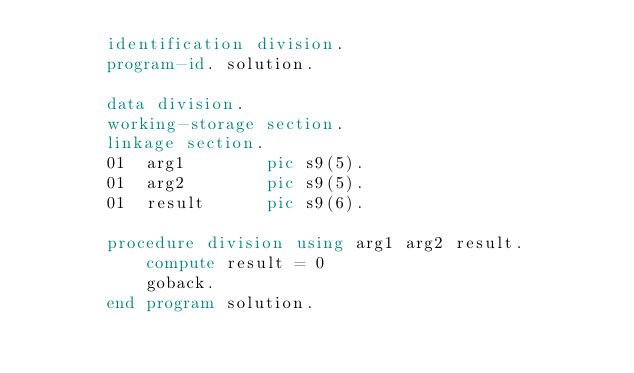<code> <loc_0><loc_0><loc_500><loc_500><_COBOL_>       identification division.
       program-id. solution.

       data division.
       working-storage section.
       linkage section.
       01  arg1        pic s9(5).
       01  arg2        pic s9(5).
       01  result      pic s9(6).

       procedure division using arg1 arg2 result.
           compute result = 0
           goback.
       end program solution.</code> 